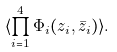<formula> <loc_0><loc_0><loc_500><loc_500>\langle \prod _ { i = 1 } ^ { 4 } \Phi _ { i } ( z _ { i } , \bar { z } _ { i } ) \rangle .</formula> 